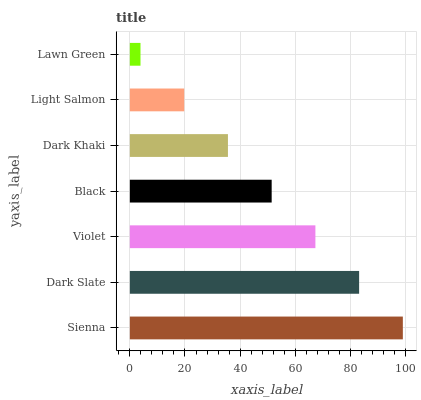Is Lawn Green the minimum?
Answer yes or no. Yes. Is Sienna the maximum?
Answer yes or no. Yes. Is Dark Slate the minimum?
Answer yes or no. No. Is Dark Slate the maximum?
Answer yes or no. No. Is Sienna greater than Dark Slate?
Answer yes or no. Yes. Is Dark Slate less than Sienna?
Answer yes or no. Yes. Is Dark Slate greater than Sienna?
Answer yes or no. No. Is Sienna less than Dark Slate?
Answer yes or no. No. Is Black the high median?
Answer yes or no. Yes. Is Black the low median?
Answer yes or no. Yes. Is Light Salmon the high median?
Answer yes or no. No. Is Light Salmon the low median?
Answer yes or no. No. 